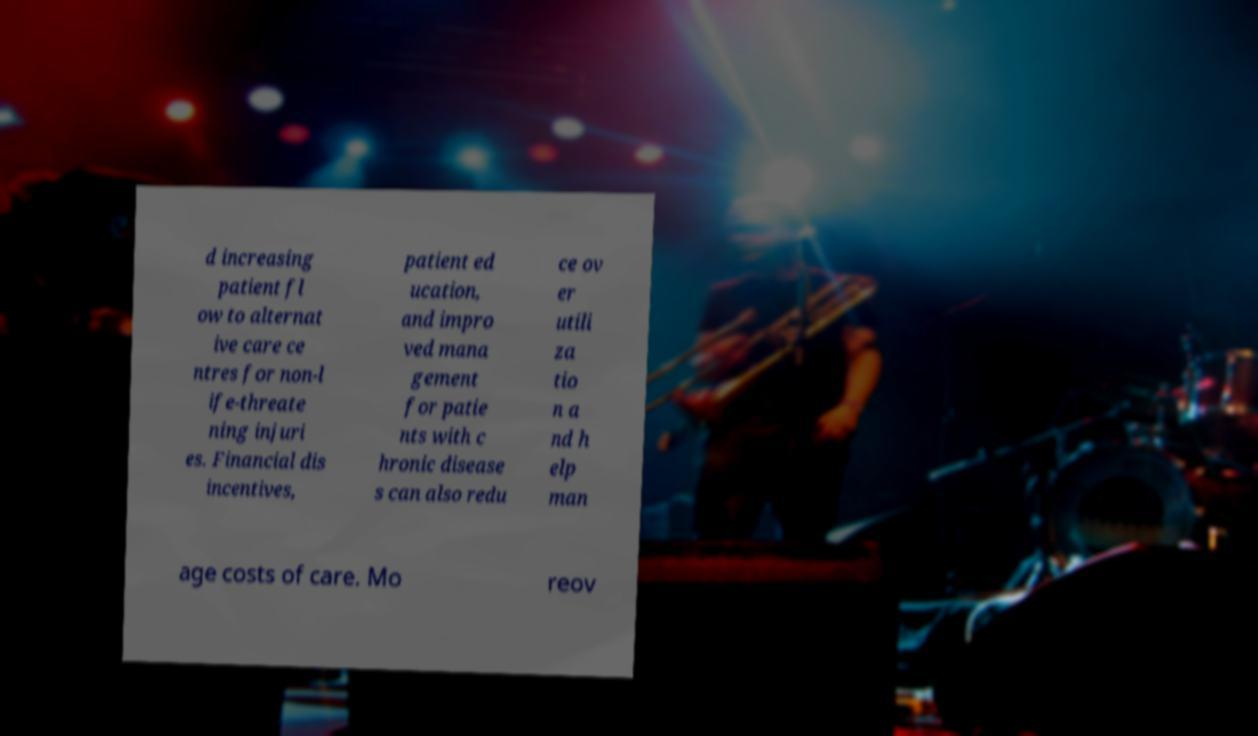Could you extract and type out the text from this image? d increasing patient fl ow to alternat ive care ce ntres for non-l ife-threate ning injuri es. Financial dis incentives, patient ed ucation, and impro ved mana gement for patie nts with c hronic disease s can also redu ce ov er utili za tio n a nd h elp man age costs of care. Mo reov 